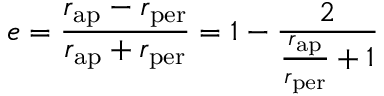<formula> <loc_0><loc_0><loc_500><loc_500>e = { \frac { r _ { a p } - r _ { p e r } } { r _ { a p } + r _ { p e r } } } = 1 - { \frac { 2 } { { \frac { r _ { a p } } { r _ { p e r } } } + 1 } }</formula> 